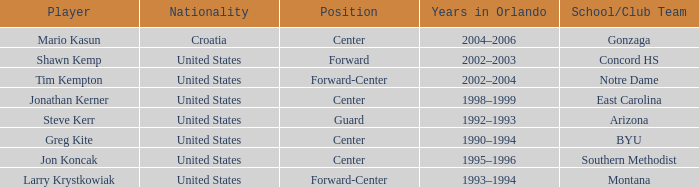What nationality has jon koncak as the player? United States. 